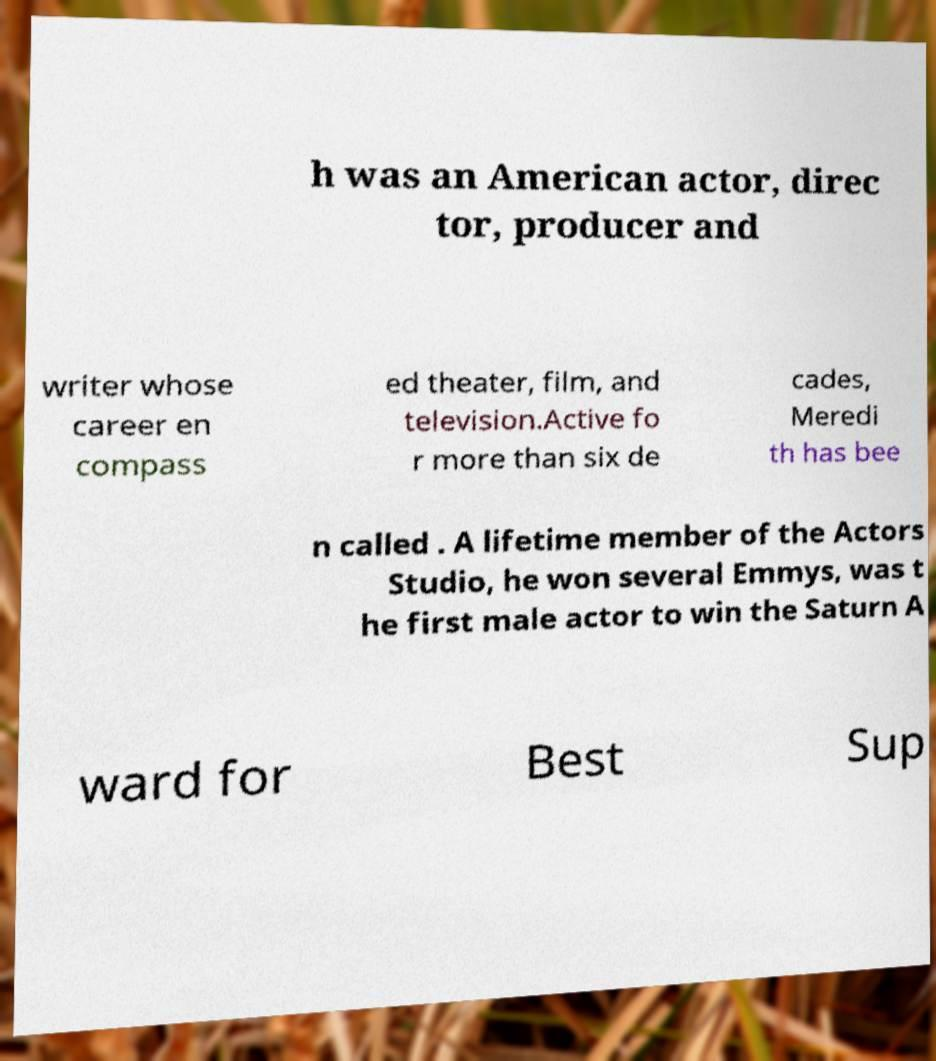Could you extract and type out the text from this image? h was an American actor, direc tor, producer and writer whose career en compass ed theater, film, and television.Active fo r more than six de cades, Meredi th has bee n called . A lifetime member of the Actors Studio, he won several Emmys, was t he first male actor to win the Saturn A ward for Best Sup 